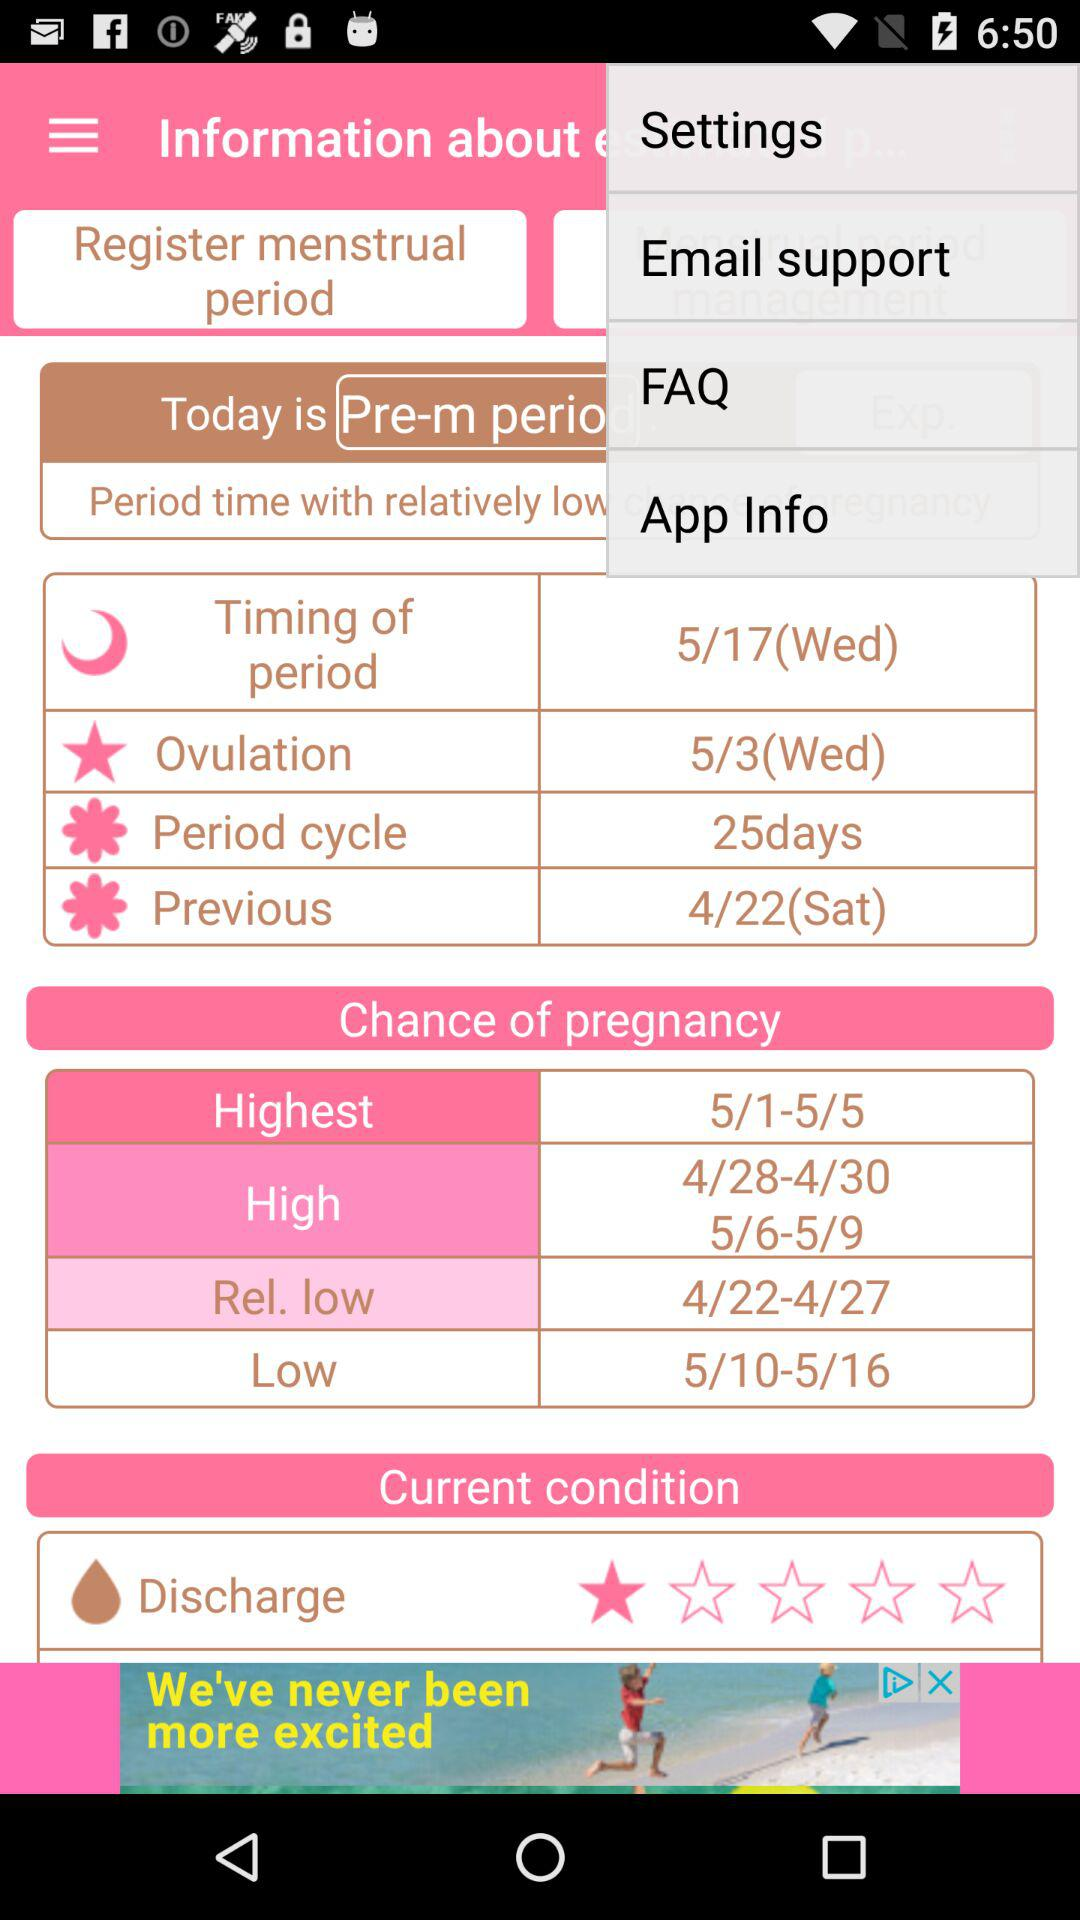What is the previous period date? The previous period date is Saturday, April 22. 